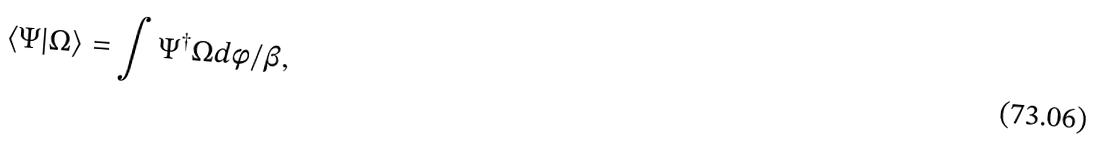Convert formula to latex. <formula><loc_0><loc_0><loc_500><loc_500>\langle \Psi | \Omega \rangle = \int \Psi ^ { \dag } \Omega d \phi / \beta ,</formula> 